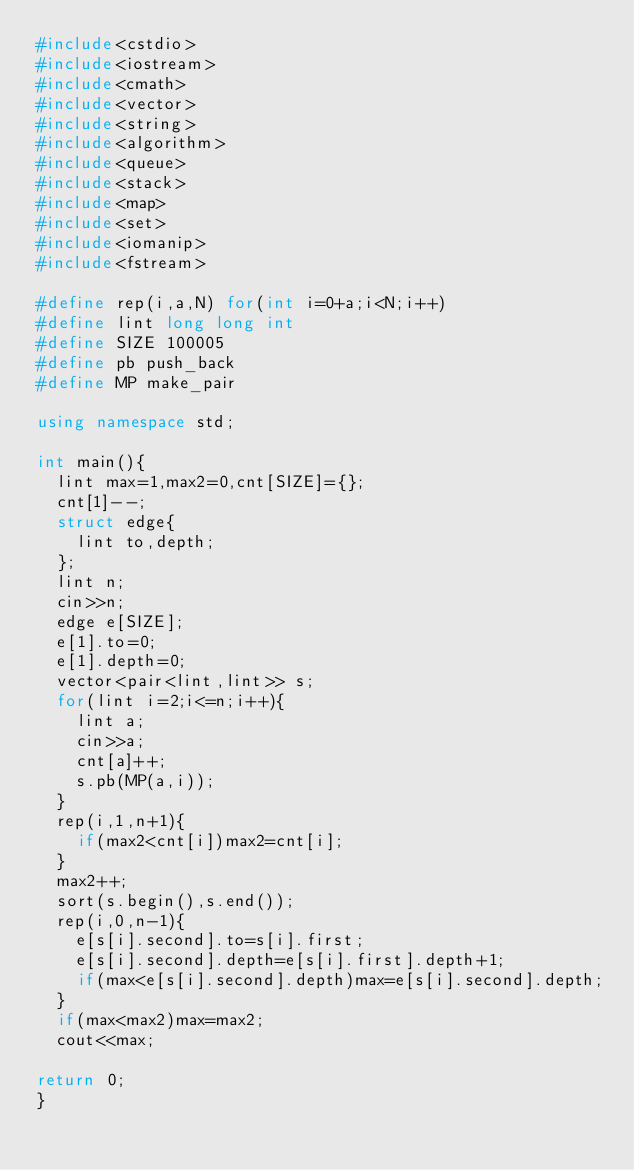Convert code to text. <code><loc_0><loc_0><loc_500><loc_500><_C++_>#include<cstdio>
#include<iostream>
#include<cmath>
#include<vector>
#include<string>
#include<algorithm>
#include<queue>
#include<stack>
#include<map>
#include<set>
#include<iomanip>
#include<fstream>

#define rep(i,a,N) for(int i=0+a;i<N;i++)
#define lint long long int
#define SIZE 100005
#define pb push_back
#define MP make_pair

using namespace std;

int main(){
	lint max=1,max2=0,cnt[SIZE]={};
	cnt[1]--;
	struct edge{
		lint to,depth;
	};
	lint n;
	cin>>n;
	edge e[SIZE];
	e[1].to=0;
	e[1].depth=0;
	vector<pair<lint,lint>> s;
	for(lint i=2;i<=n;i++){
		lint a;
		cin>>a;
		cnt[a]++;
		s.pb(MP(a,i));
	}
	rep(i,1,n+1){
		if(max2<cnt[i])max2=cnt[i];
	}
	max2++;
	sort(s.begin(),s.end());
	rep(i,0,n-1){
		e[s[i].second].to=s[i].first;
		e[s[i].second].depth=e[s[i].first].depth+1;
		if(max<e[s[i].second].depth)max=e[s[i].second].depth;
	}
	if(max<max2)max=max2;
	cout<<max;

return 0;
}</code> 